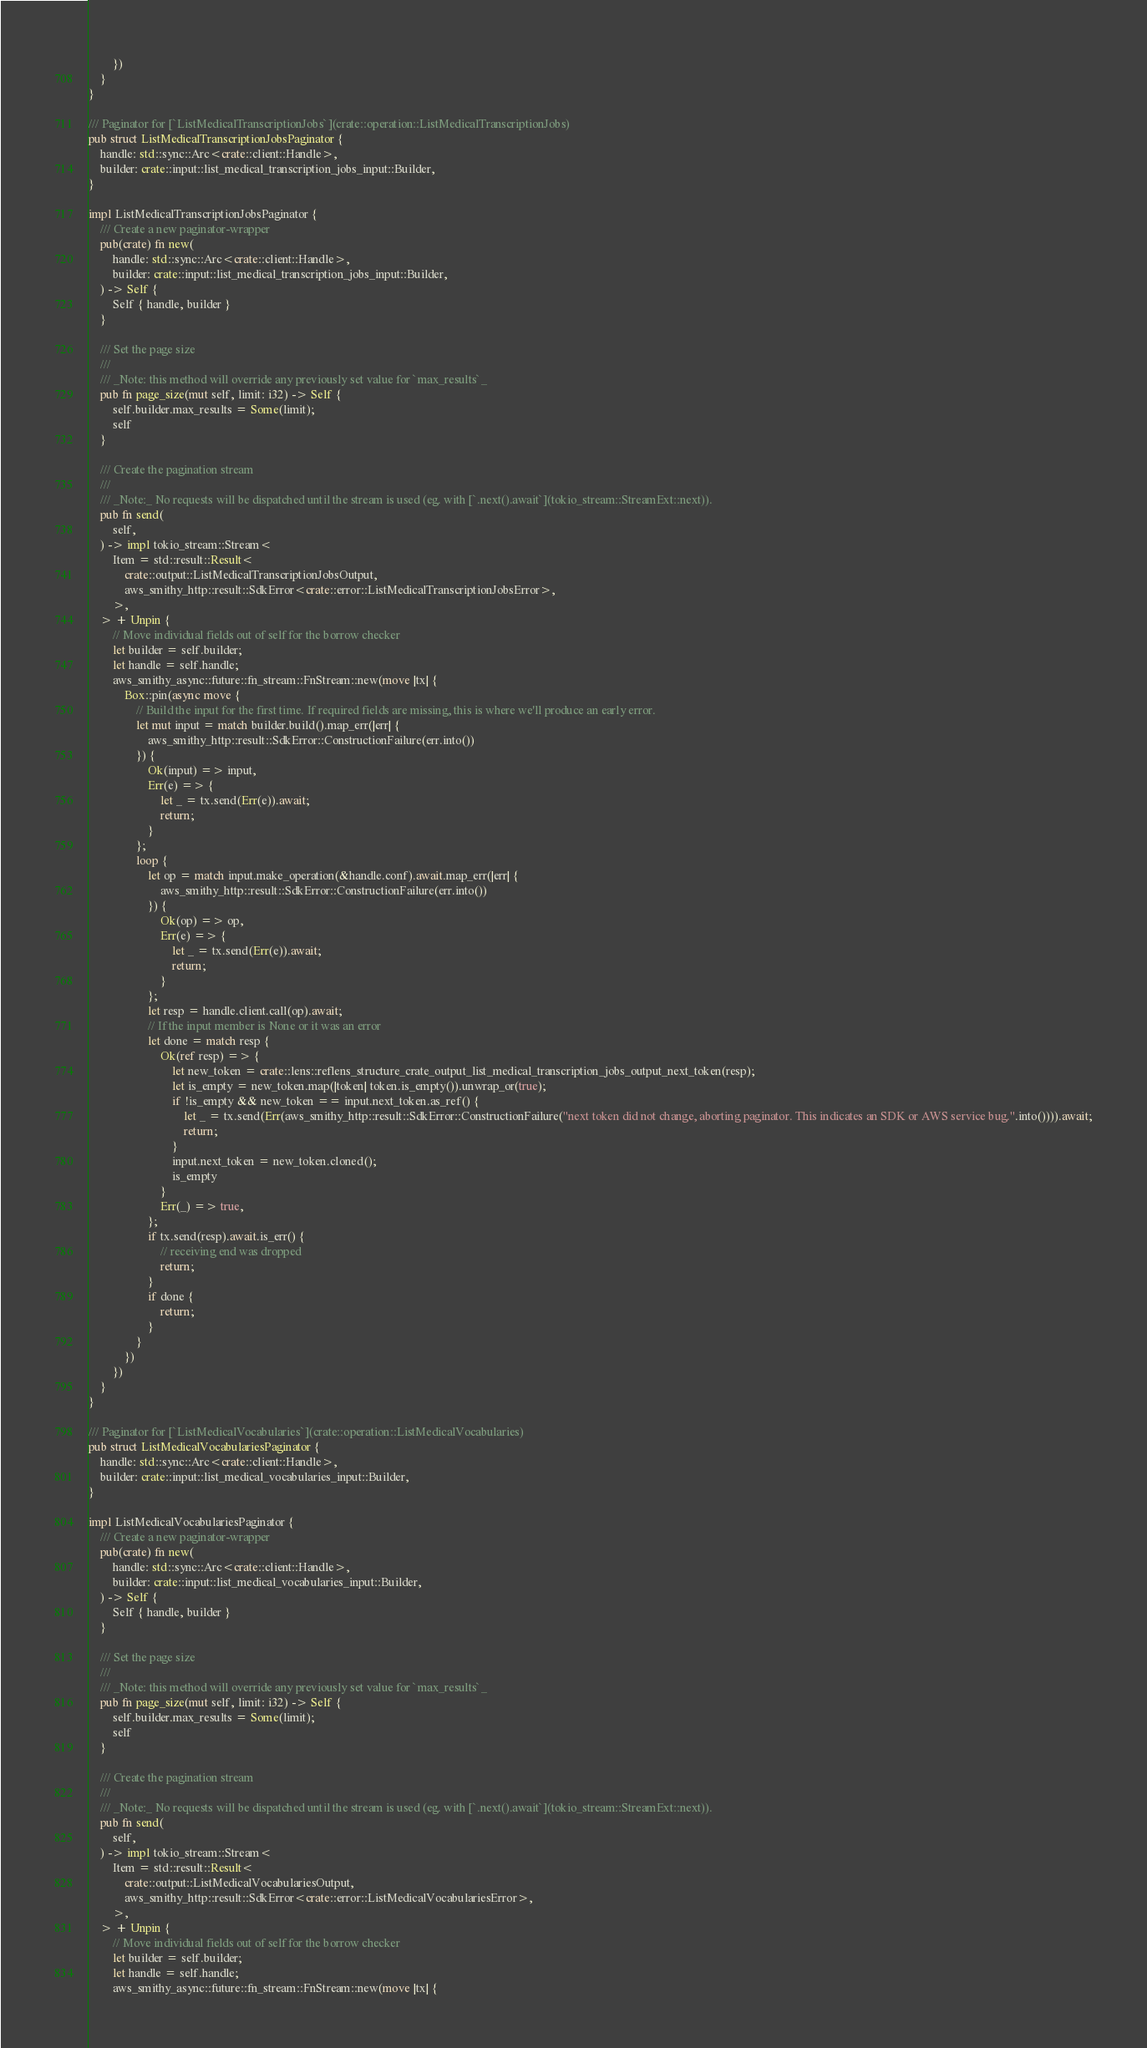Convert code to text. <code><loc_0><loc_0><loc_500><loc_500><_Rust_>        })
    }
}

/// Paginator for [`ListMedicalTranscriptionJobs`](crate::operation::ListMedicalTranscriptionJobs)
pub struct ListMedicalTranscriptionJobsPaginator {
    handle: std::sync::Arc<crate::client::Handle>,
    builder: crate::input::list_medical_transcription_jobs_input::Builder,
}

impl ListMedicalTranscriptionJobsPaginator {
    /// Create a new paginator-wrapper
    pub(crate) fn new(
        handle: std::sync::Arc<crate::client::Handle>,
        builder: crate::input::list_medical_transcription_jobs_input::Builder,
    ) -> Self {
        Self { handle, builder }
    }

    /// Set the page size
    ///
    /// _Note: this method will override any previously set value for `max_results`_
    pub fn page_size(mut self, limit: i32) -> Self {
        self.builder.max_results = Some(limit);
        self
    }

    /// Create the pagination stream
    ///
    /// _Note:_ No requests will be dispatched until the stream is used (eg. with [`.next().await`](tokio_stream::StreamExt::next)).
    pub fn send(
        self,
    ) -> impl tokio_stream::Stream<
        Item = std::result::Result<
            crate::output::ListMedicalTranscriptionJobsOutput,
            aws_smithy_http::result::SdkError<crate::error::ListMedicalTranscriptionJobsError>,
        >,
    > + Unpin {
        // Move individual fields out of self for the borrow checker
        let builder = self.builder;
        let handle = self.handle;
        aws_smithy_async::future::fn_stream::FnStream::new(move |tx| {
            Box::pin(async move {
                // Build the input for the first time. If required fields are missing, this is where we'll produce an early error.
                let mut input = match builder.build().map_err(|err| {
                    aws_smithy_http::result::SdkError::ConstructionFailure(err.into())
                }) {
                    Ok(input) => input,
                    Err(e) => {
                        let _ = tx.send(Err(e)).await;
                        return;
                    }
                };
                loop {
                    let op = match input.make_operation(&handle.conf).await.map_err(|err| {
                        aws_smithy_http::result::SdkError::ConstructionFailure(err.into())
                    }) {
                        Ok(op) => op,
                        Err(e) => {
                            let _ = tx.send(Err(e)).await;
                            return;
                        }
                    };
                    let resp = handle.client.call(op).await;
                    // If the input member is None or it was an error
                    let done = match resp {
                        Ok(ref resp) => {
                            let new_token = crate::lens::reflens_structure_crate_output_list_medical_transcription_jobs_output_next_token(resp);
                            let is_empty = new_token.map(|token| token.is_empty()).unwrap_or(true);
                            if !is_empty && new_token == input.next_token.as_ref() {
                                let _ = tx.send(Err(aws_smithy_http::result::SdkError::ConstructionFailure("next token did not change, aborting paginator. This indicates an SDK or AWS service bug.".into()))).await;
                                return;
                            }
                            input.next_token = new_token.cloned();
                            is_empty
                        }
                        Err(_) => true,
                    };
                    if tx.send(resp).await.is_err() {
                        // receiving end was dropped
                        return;
                    }
                    if done {
                        return;
                    }
                }
            })
        })
    }
}

/// Paginator for [`ListMedicalVocabularies`](crate::operation::ListMedicalVocabularies)
pub struct ListMedicalVocabulariesPaginator {
    handle: std::sync::Arc<crate::client::Handle>,
    builder: crate::input::list_medical_vocabularies_input::Builder,
}

impl ListMedicalVocabulariesPaginator {
    /// Create a new paginator-wrapper
    pub(crate) fn new(
        handle: std::sync::Arc<crate::client::Handle>,
        builder: crate::input::list_medical_vocabularies_input::Builder,
    ) -> Self {
        Self { handle, builder }
    }

    /// Set the page size
    ///
    /// _Note: this method will override any previously set value for `max_results`_
    pub fn page_size(mut self, limit: i32) -> Self {
        self.builder.max_results = Some(limit);
        self
    }

    /// Create the pagination stream
    ///
    /// _Note:_ No requests will be dispatched until the stream is used (eg. with [`.next().await`](tokio_stream::StreamExt::next)).
    pub fn send(
        self,
    ) -> impl tokio_stream::Stream<
        Item = std::result::Result<
            crate::output::ListMedicalVocabulariesOutput,
            aws_smithy_http::result::SdkError<crate::error::ListMedicalVocabulariesError>,
        >,
    > + Unpin {
        // Move individual fields out of self for the borrow checker
        let builder = self.builder;
        let handle = self.handle;
        aws_smithy_async::future::fn_stream::FnStream::new(move |tx| {</code> 